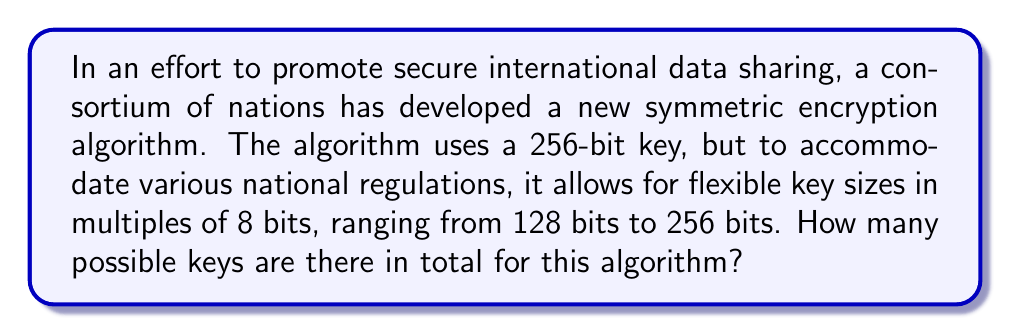Show me your answer to this math problem. Let's approach this step-by-step:

1) First, we need to identify the possible key sizes:
   128, 136, 144, 152, 160, 168, 176, 184, 192, 200, 208, 216, 224, 232, 240, 248, and 256 bits

2) For each key size, we need to calculate the number of possible keys:
   - For a key of size $n$ bits, there are $2^n$ possible keys

3) Let's calculate this for each key size:
   $$128\text{ bits}: 2^{128}$$
   $$136\text{ bits}: 2^{136}$$
   $$144\text{ bits}: 2^{144}$$
   ...
   $$248\text{ bits}: 2^{248}$$
   $$256\text{ bits}: 2^{256}$$

4) To get the total number of possible keys, we need to sum all these values:
   $$\text{Total} = 2^{128} + 2^{136} + 2^{144} + ... + 2^{248} + 2^{256}$$

5) This can be written as a geometric series:
   $$\text{Total} = \sum_{n=16}^{32} 2^{8n}$$

6) The sum of a geometric series is given by the formula:
   $$S_n = \frac{a(1-r^n)}{1-r}$$
   where $a$ is the first term, $r$ is the common ratio, and $n$ is the number of terms

7) In our case:
   $a = 2^{128}$
   $r = 2^8 = 256$
   $n = 17$ (there are 17 terms from 128 bits to 256 bits, inclusive)

8) Plugging these into the formula:
   $$\text{Total} = \frac{2^{128}(1-256^{17})}{1-256}$$

9) Simplifying:
   $$\text{Total} = \frac{2^{128}(256^{17}-1)}{255}$$

This is the exact value, but it's an extremely large number.
Answer: $\frac{2^{128}(256^{17}-1)}{255}$ 